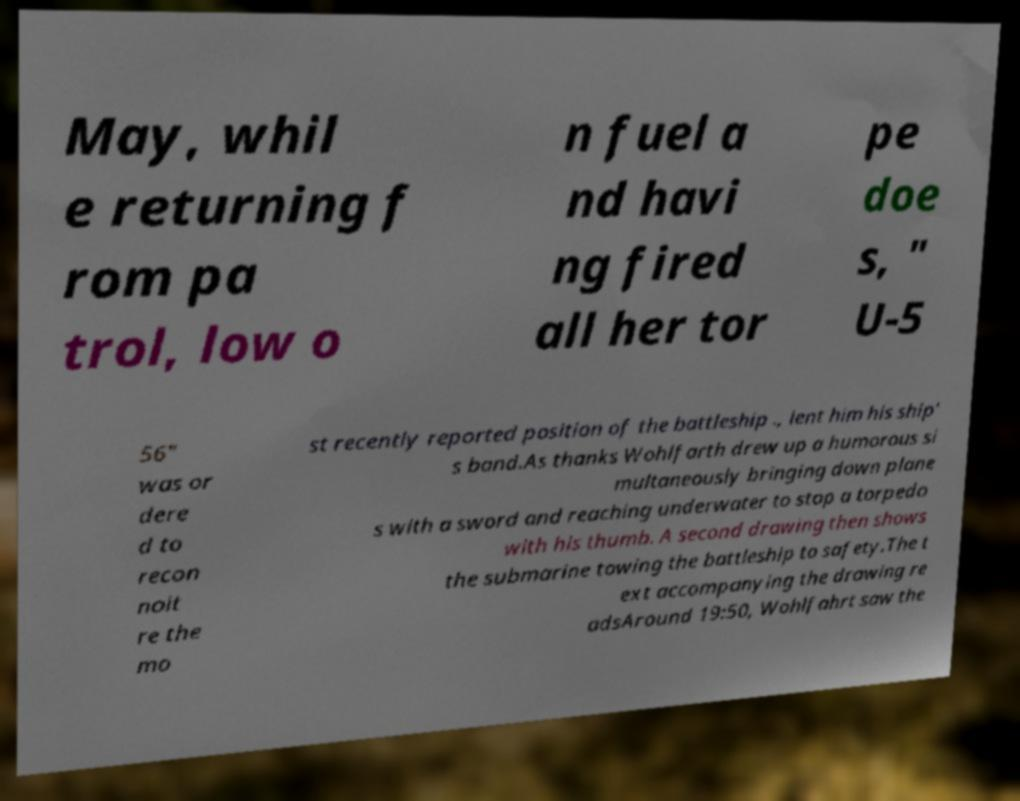Could you extract and type out the text from this image? May, whil e returning f rom pa trol, low o n fuel a nd havi ng fired all her tor pe doe s, " U-5 56" was or dere d to recon noit re the mo st recently reported position of the battleship ., lent him his ship' s band.As thanks Wohlfarth drew up a humorous si multaneously bringing down plane s with a sword and reaching underwater to stop a torpedo with his thumb. A second drawing then shows the submarine towing the battleship to safety.The t ext accompanying the drawing re adsAround 19:50, Wohlfahrt saw the 